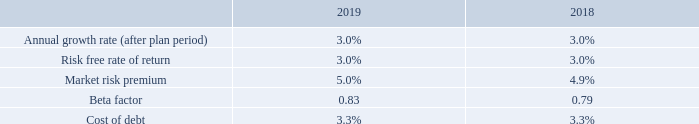The pre-tax discount rate used within the recoverable amount calculations was 8.5% (2018: 8.0%) and is based upon the weighted average cost of capital reflecting specific principal risks and uncertainties. The discount rate takes into account the risk-free rate of return, the market risk premium and beta factor reflecting the average beta for the Group and comparator companies which are used in deriving the cost of equity.
The same discount rate has been applied to both CGUs as the principal risks and uncertainties associated with the Group, as highlighted on pages 30 to 33, would also impact each CGU in a similar manner. The Board acknowledges that there are additional factors that could impact the risk profile of each CGU, which have been considered by way of sensitivity analysis performed as part of the annual impairment tests.
Key drivers to future growth rates are dependent on the Group’s ability to maintain and grow income streams whilst effectively managing operating costs. The level of headroom may change if different growth rate assumptions or a different pre-tax discount rate were used in the cash flow projections. Where the value-in-use calculations suggest an impairment, the Board would consider alternative use values prior to realising any impairment, being the fair value less costs to dispose.
The key assumptions used for value-in-use calculations are as follows:
Having completed the 2019 impairment review, no impairment has been recognised in relation to the CGUs (2018: no impairment). Sensitivity
analysis has been performed in assessing the recoverable amounts of goodwill. There are no changes to the key assumptions of growth rate or
discount rate that are considered by the Directors to be reasonably possible, which give rise to an impairment of goodwill relating to the CGUs.
What are the key drivers to future growth rates dependent on? The group’s ability to maintain and grow income streams whilst effectively managing operating costs. In what situations might the level of headroom change? If different growth rate assumptions or a different pre-tax discount rate were used in the cash flow projections. What are the key assumptions used for value-in-use calculations in the table? Annual growth rate (after plan period), risk free rate of return, market risk premium, beta factor, cost of debt. In which year was the market risk premium percentage larger? 5.0%>4.9%
Answer: 2019. What was the change in the Beta factor in 2019 from 2018? 0.83-0.79
Answer: 0.04. What was the percentage change in the Beta factor in 2019 from 2018?
Answer scale should be: percent. (0.83-0.79)/0.79
Answer: 5.06. 